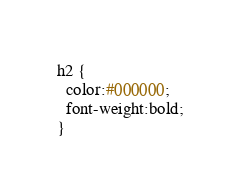Convert code to text. <code><loc_0><loc_0><loc_500><loc_500><_CSS_>h2 {
  color:#000000;
  font-weight:bold;
}
</code> 